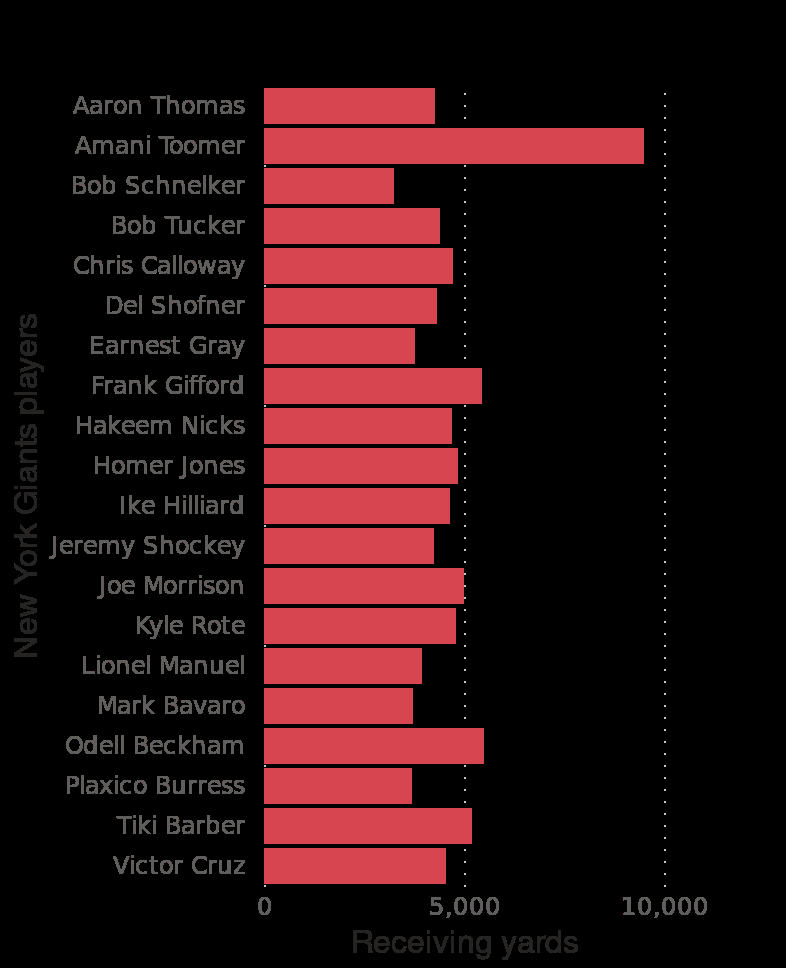<image>
please summary the statistics and relations of the chart From 1925 to 2020 the New York Giants all time receivers trend in yards, is around  5000 per 20 receiver's. Only Armani Toomer, broke the 5000 mark and managed nearly 10000. Who is the player with the most receiving yards for the New York Giants?  The player with the most receiving yards for the New York Giants is Aaron Thomas. What is the average number of yards for the New York Giants' top 20 receivers from 1925 to 2020?  Around 5000 yards. 